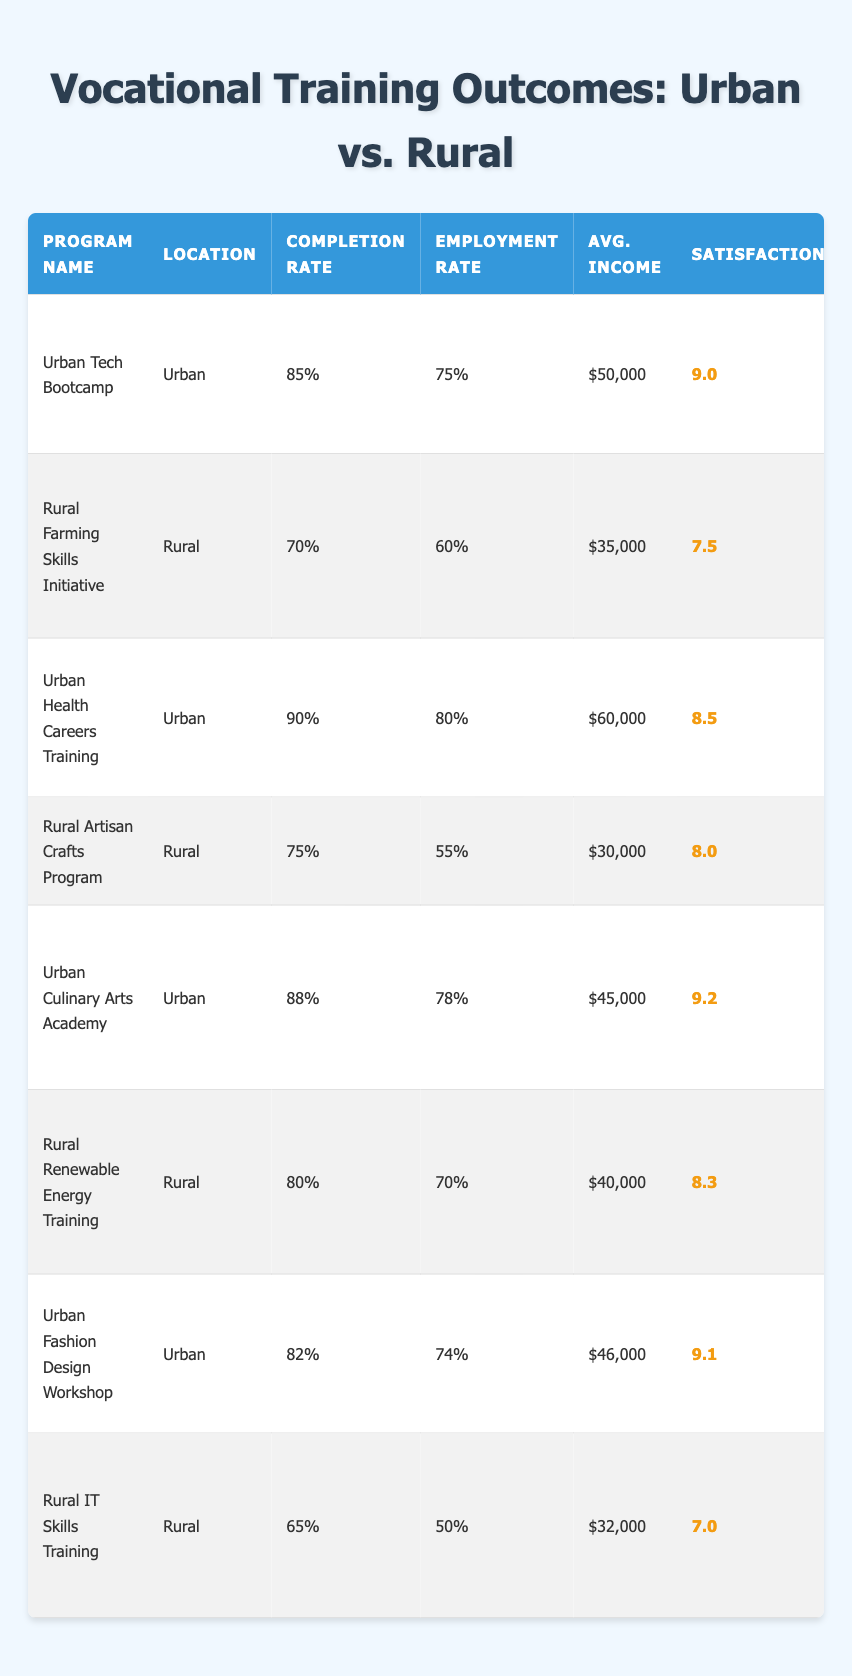What is the completion rate of the Urban Tech Bootcamp? The table shows that the completion rate for the Urban Tech Bootcamp is listed under the "Completion Rate" column, which is 85%.
Answer: 85% What skills are taught in the Rural Renewable Energy Training program? The skills taught in the Rural Renewable Energy Training program can be found in the "Skills Taught" column, which lists "Solar Panel Installation, Wind Energy Systems, Energy Efficiency."
Answer: Solar Panel Installation, Wind Energy Systems, Energy Efficiency Which program has the highest youth satisfaction score? By comparing the youth satisfaction scores listed in the table, the Urban Culinary Arts Academy has the highest score of 9.2.
Answer: Urban Culinary Arts Academy What is the average income post-training for the rural programs? The average incomes post-training for the rural programs are $35,000 (Farming), $30,000 (Artisan Crafts), $40,000 (Renewable Energy), and $32,000 (IT Skills). The average is calculated as follows: (35,000 + 30,000 + 40,000 + 32,000) / 4 = $34,250.
Answer: $34,250 Is the employment rate higher in urban or rural settings? The average employment rates can be compared: Urban (75% + 80% + 78% + 74%) / 4 = 76.75%, and Rural (60% + 55% + 70% + 50%) / 4 = 58.75%. Urban has a higher average employment rate than rural.
Answer: Yes How much greater is the average income for urban programs compared to rural programs? The average income for urban programs is ($50,000 + $60,000 + $45,000 + $46,000) / 4 = $50,250. The average income for rural programs is ($35,000 + $30,000 + $40,000 + $32,000) / 4 = $34,250. The difference is $50,250 - $34,250 = $16,000.
Answer: $16,000 Which program has the lowest completion rate and what is that rate? The program with the lowest completion rate is the Rural IT Skills Training, with a completion rate of 65% as noted under the "Completion Rate" column.
Answer: 65% What proportion of urban programs have completion rates above 80%? There are four urban programs: Urban Tech Bootcamp (85%), Urban Health Careers Training (90%), Urban Culinary Arts Academy (88%), and Urban Fashion Design Workshop (82%). Three out of the four have completion rates above 80%. Thus, the proportion is 3/4 = 75%.
Answer: 75% If we were to categorize programs by location, how many urban programs exceeded the average satisfaction score of 8? The average satisfaction score for urban programs is calculated as (9.0 + 8.5 + 9.2 + 9.1) / 4 = 8.95. The urban programs with scores above 8.95 are Urban Culinary Arts Academy (9.2) and Urban Fashion Design Workshop (9.1). This gives us 2 programs.
Answer: 2 Are there any rural programs with a youth satisfaction score above 8? The rural programs have scores of 7.5 (Farming), 8.0 (Artisan Crafts), 8.3 (Renewable Energy), and 7.0 (IT Skills). The Rural Renewable Energy Training is the only program with a score above 8.
Answer: Yes 